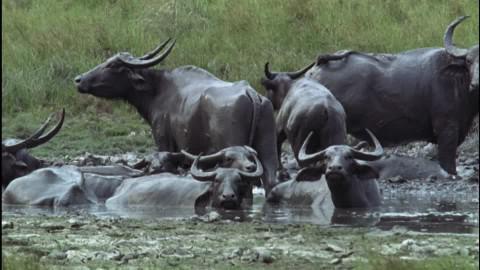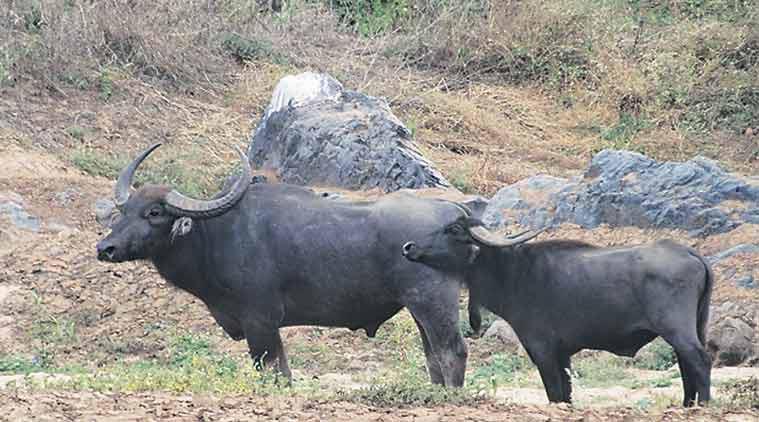The first image is the image on the left, the second image is the image on the right. For the images shown, is this caption "The animals in the left photo are standing in water." true? Answer yes or no. Yes. The first image is the image on the left, the second image is the image on the right. Assess this claim about the two images: "Left image shows water buffalo standing in wet area.". Correct or not? Answer yes or no. Yes. 